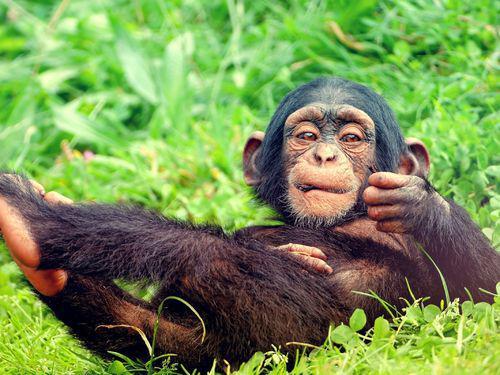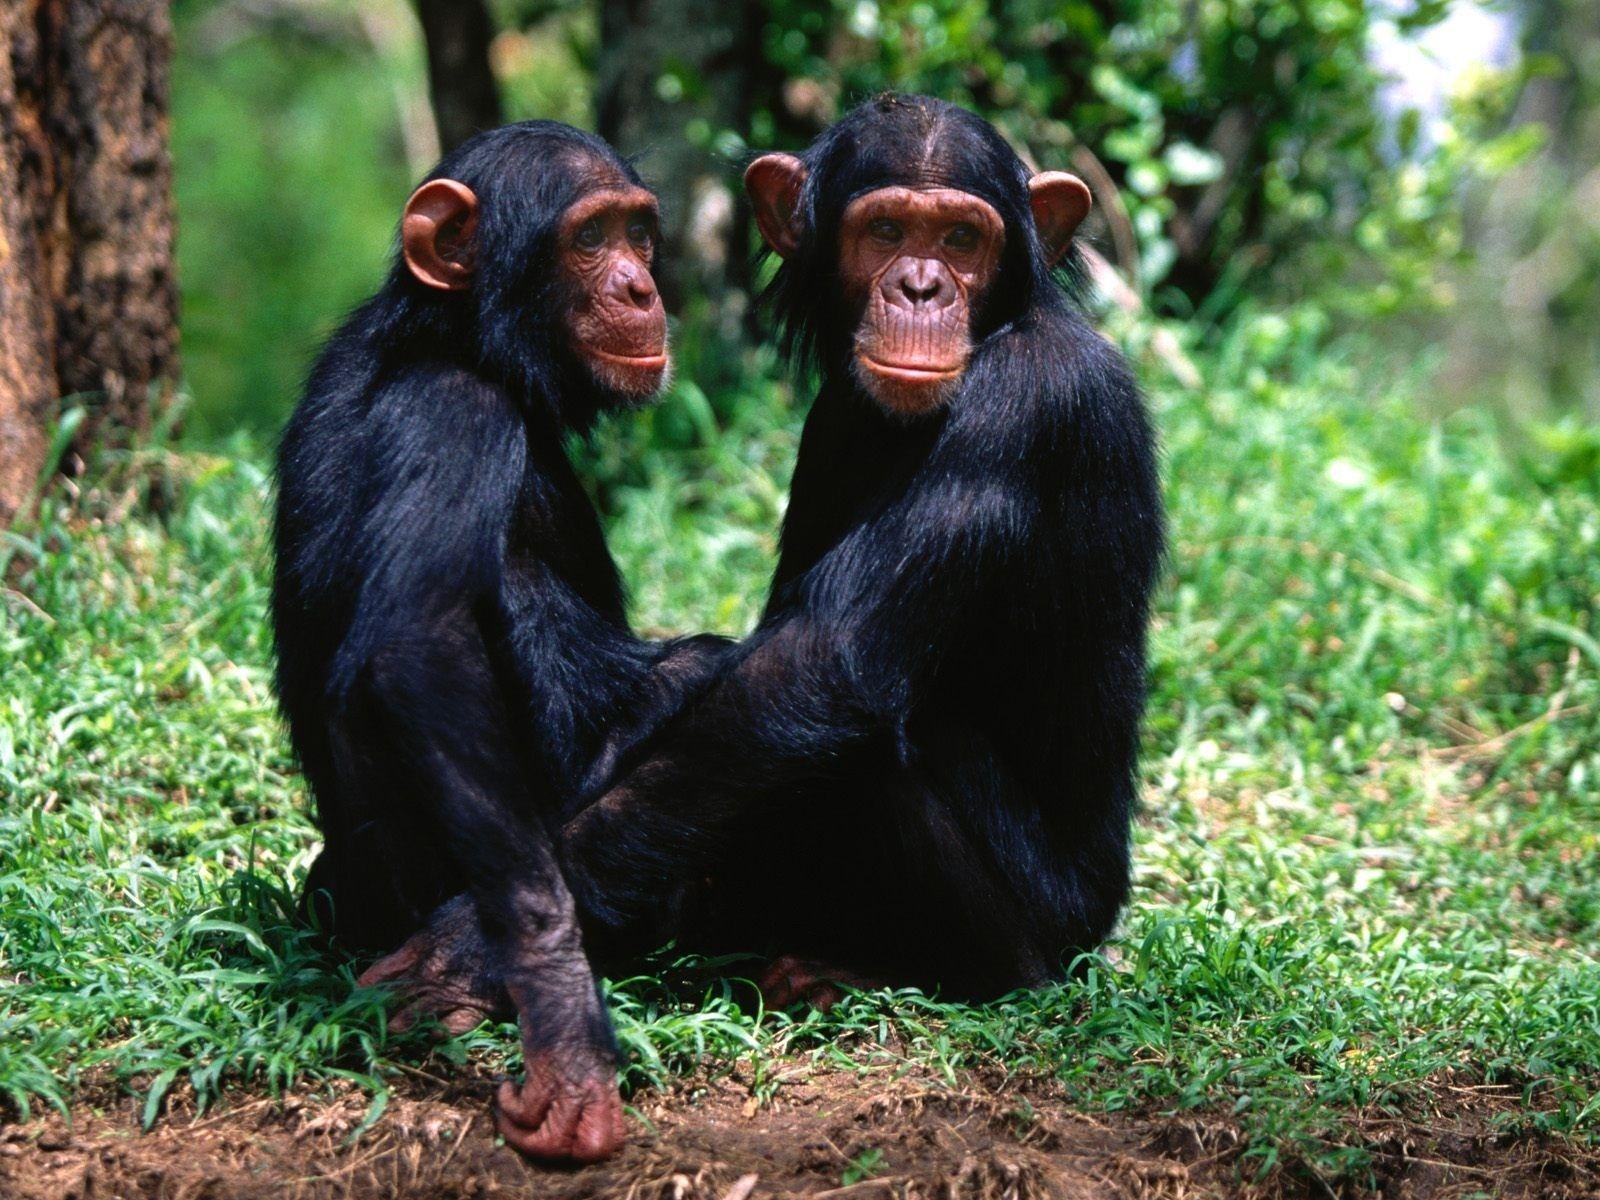The first image is the image on the left, the second image is the image on the right. Examine the images to the left and right. Is the description "There are three apes in total." accurate? Answer yes or no. Yes. 